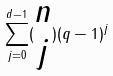Convert formula to latex. <formula><loc_0><loc_0><loc_500><loc_500>\sum _ { j = 0 } ^ { d - 1 } ( \begin{matrix} n \\ j \end{matrix} ) ( q - 1 ) ^ { j }</formula> 